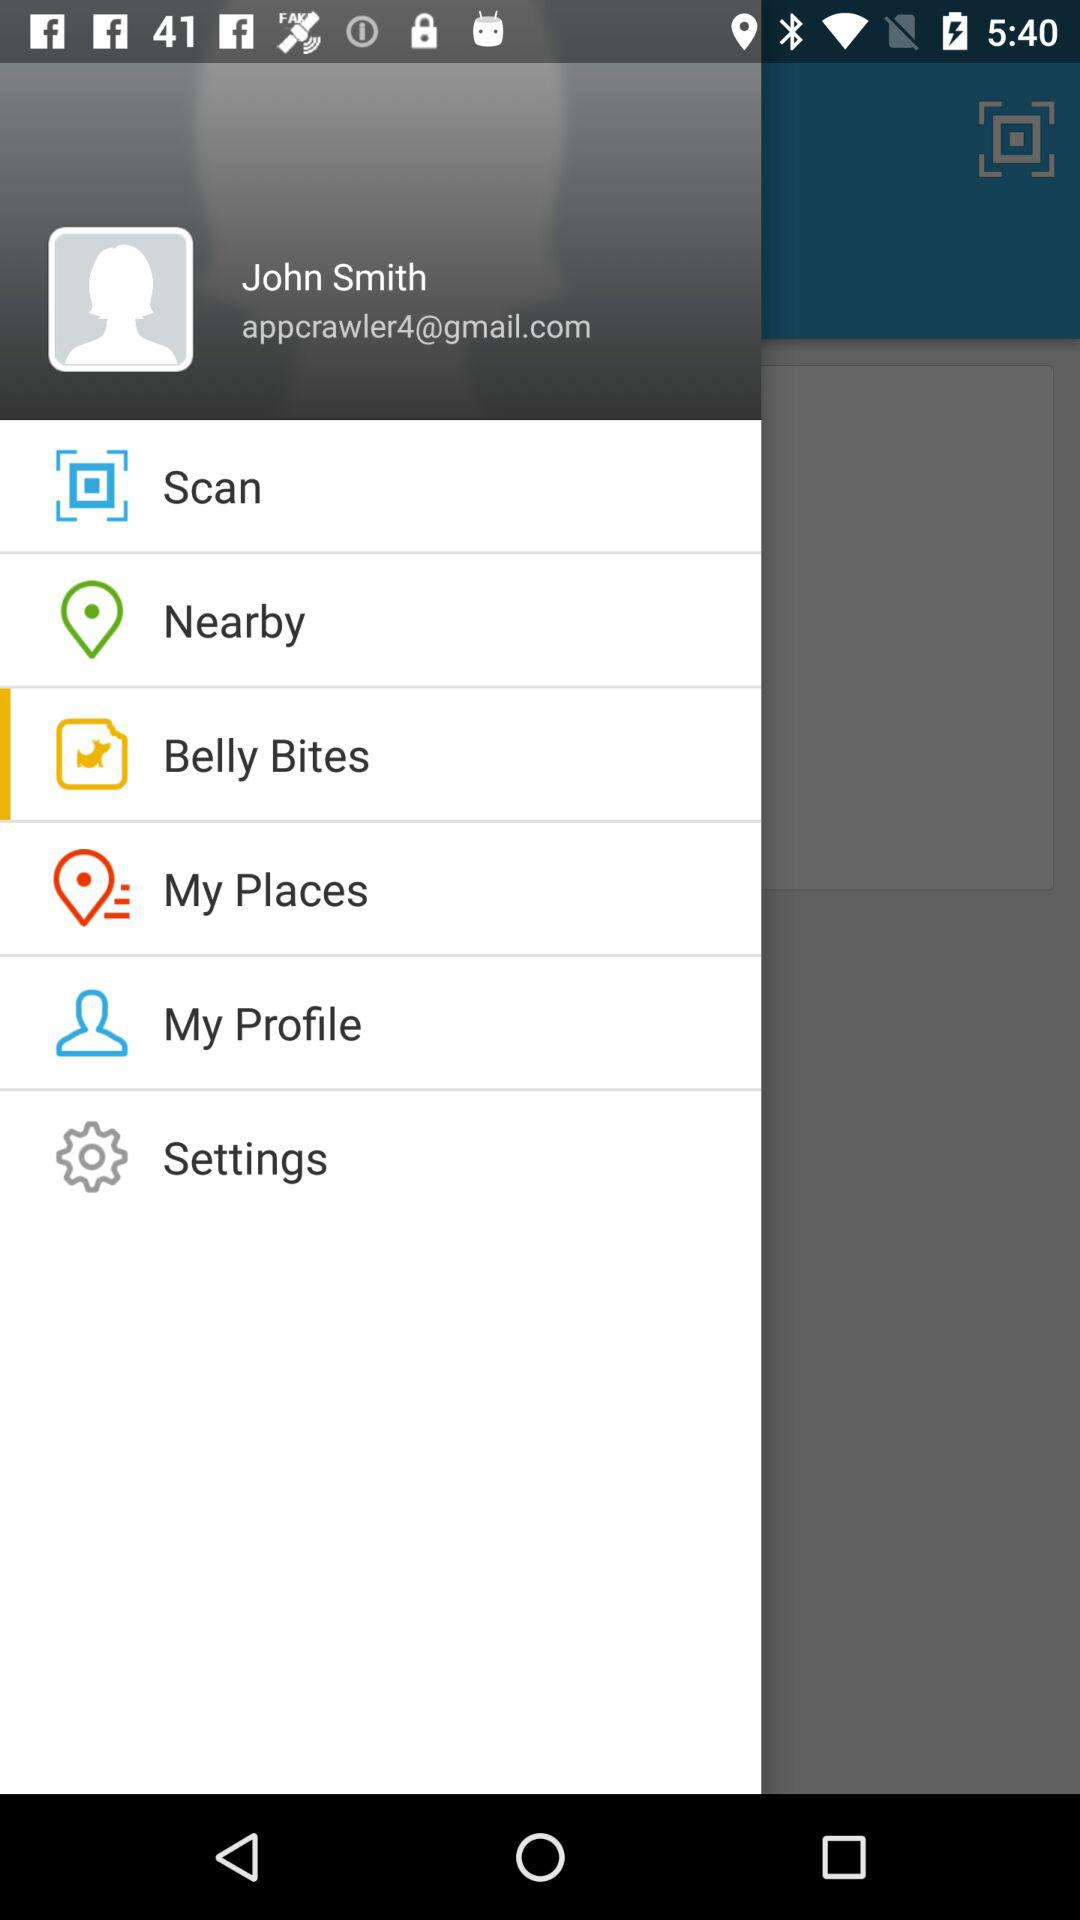What is the user email ID? The email ID is appcrawler4@gmail.com. 